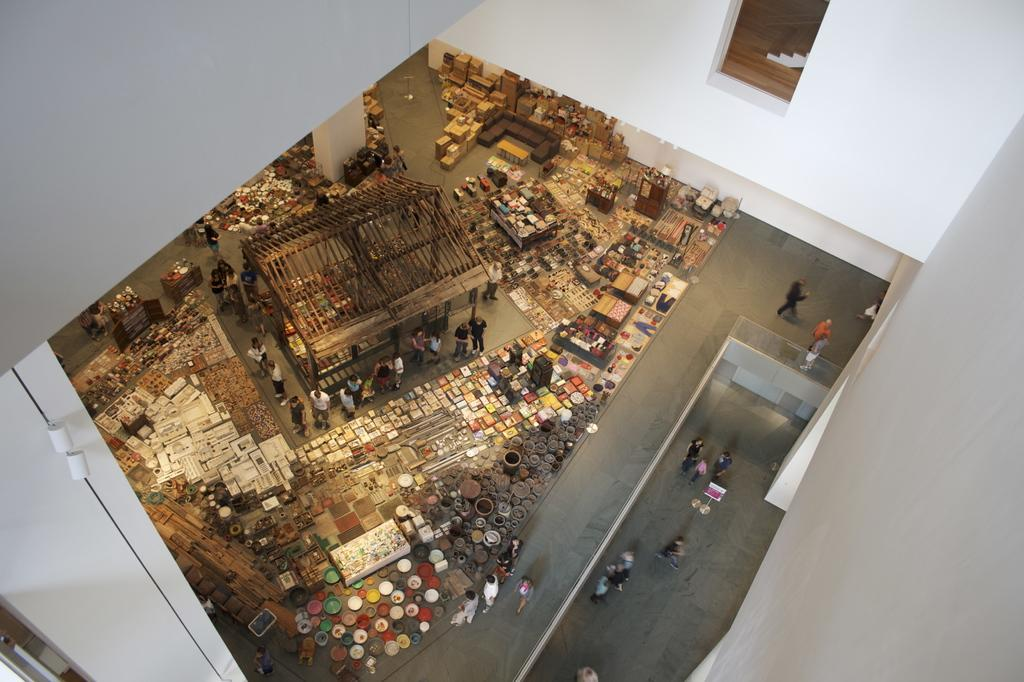Who or what can be seen in the image? There are people in the image. What objects are present in the image besides the people? There are boxes, poles, and wooden sticks in the image. How many ants can be seen climbing the poles in the image? There are no ants present in the image; it only features people, boxes, poles, and wooden sticks. 